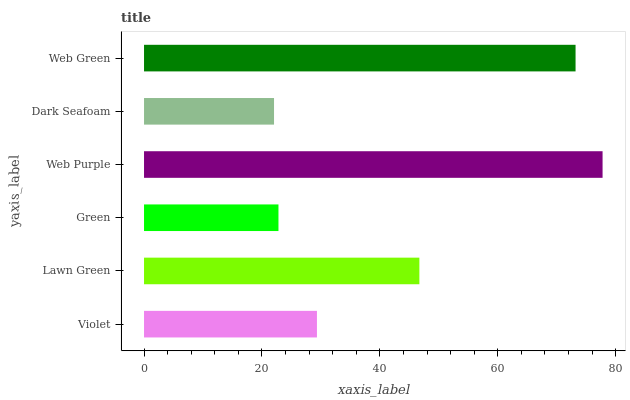Is Dark Seafoam the minimum?
Answer yes or no. Yes. Is Web Purple the maximum?
Answer yes or no. Yes. Is Lawn Green the minimum?
Answer yes or no. No. Is Lawn Green the maximum?
Answer yes or no. No. Is Lawn Green greater than Violet?
Answer yes or no. Yes. Is Violet less than Lawn Green?
Answer yes or no. Yes. Is Violet greater than Lawn Green?
Answer yes or no. No. Is Lawn Green less than Violet?
Answer yes or no. No. Is Lawn Green the high median?
Answer yes or no. Yes. Is Violet the low median?
Answer yes or no. Yes. Is Web Green the high median?
Answer yes or no. No. Is Green the low median?
Answer yes or no. No. 